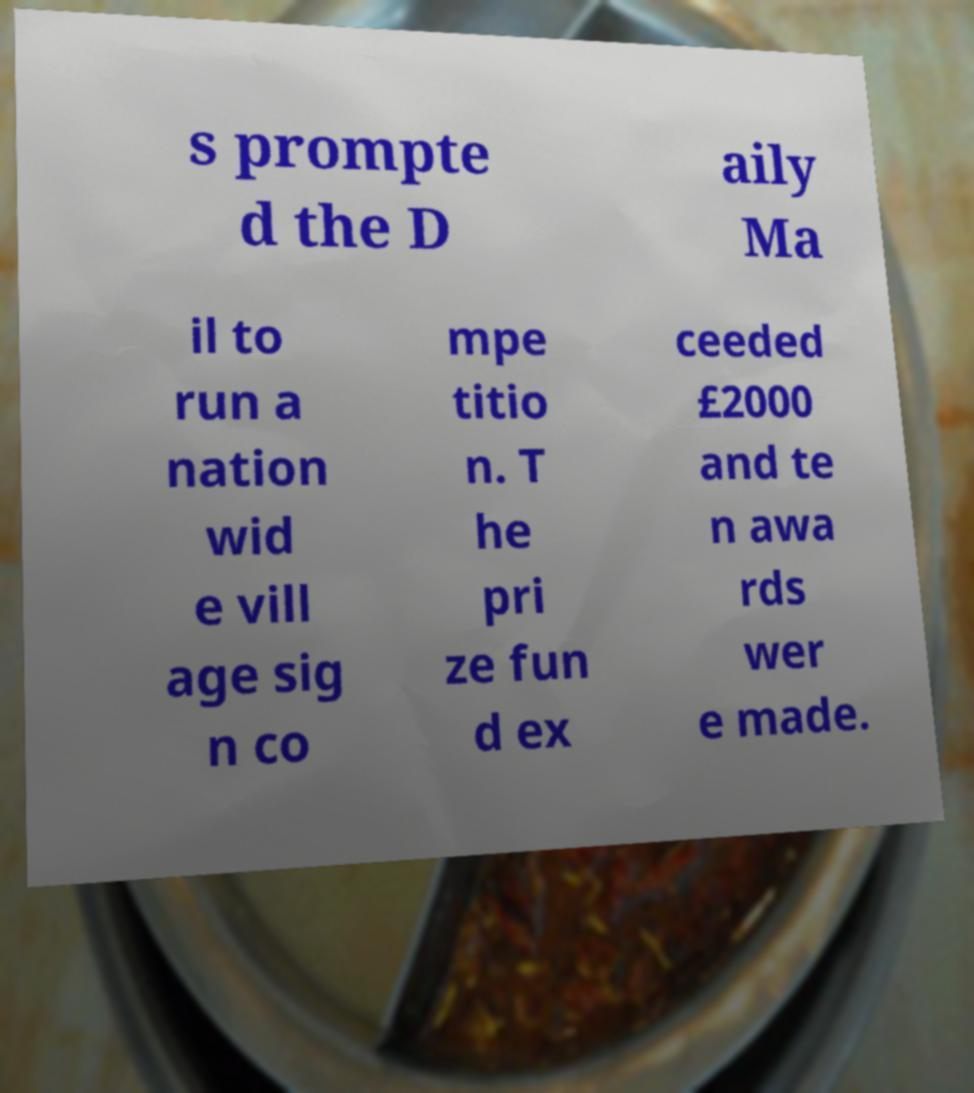There's text embedded in this image that I need extracted. Can you transcribe it verbatim? s prompte d the D aily Ma il to run a nation wid e vill age sig n co mpe titio n. T he pri ze fun d ex ceeded £2000 and te n awa rds wer e made. 